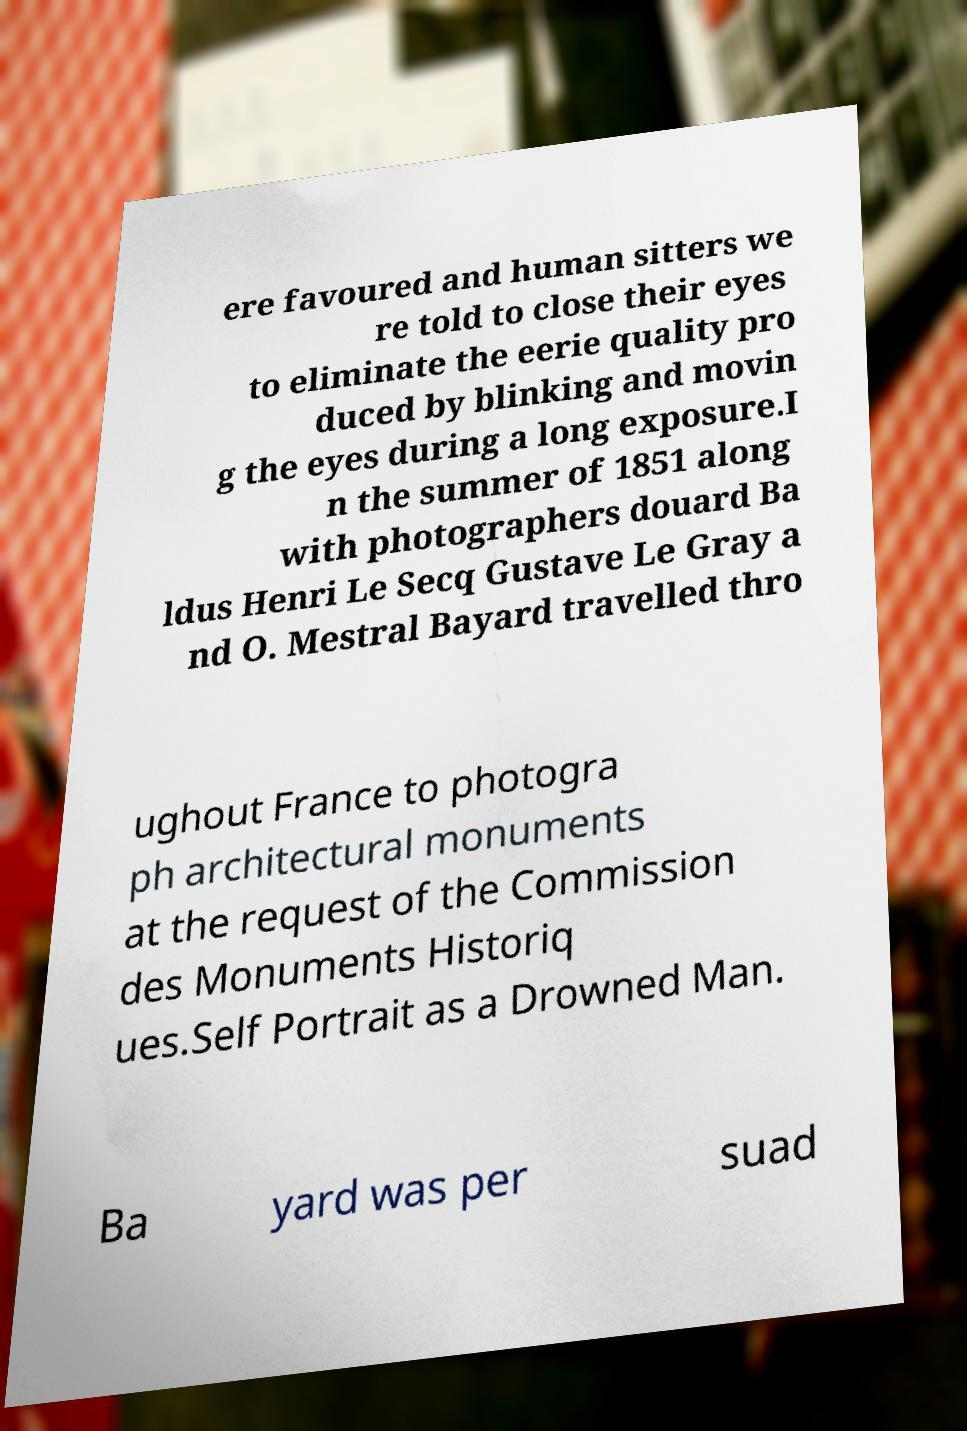What messages or text are displayed in this image? I need them in a readable, typed format. ere favoured and human sitters we re told to close their eyes to eliminate the eerie quality pro duced by blinking and movin g the eyes during a long exposure.I n the summer of 1851 along with photographers douard Ba ldus Henri Le Secq Gustave Le Gray a nd O. Mestral Bayard travelled thro ughout France to photogra ph architectural monuments at the request of the Commission des Monuments Historiq ues.Self Portrait as a Drowned Man. Ba yard was per suad 